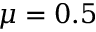Convert formula to latex. <formula><loc_0><loc_0><loc_500><loc_500>\mu = 0 . 5</formula> 